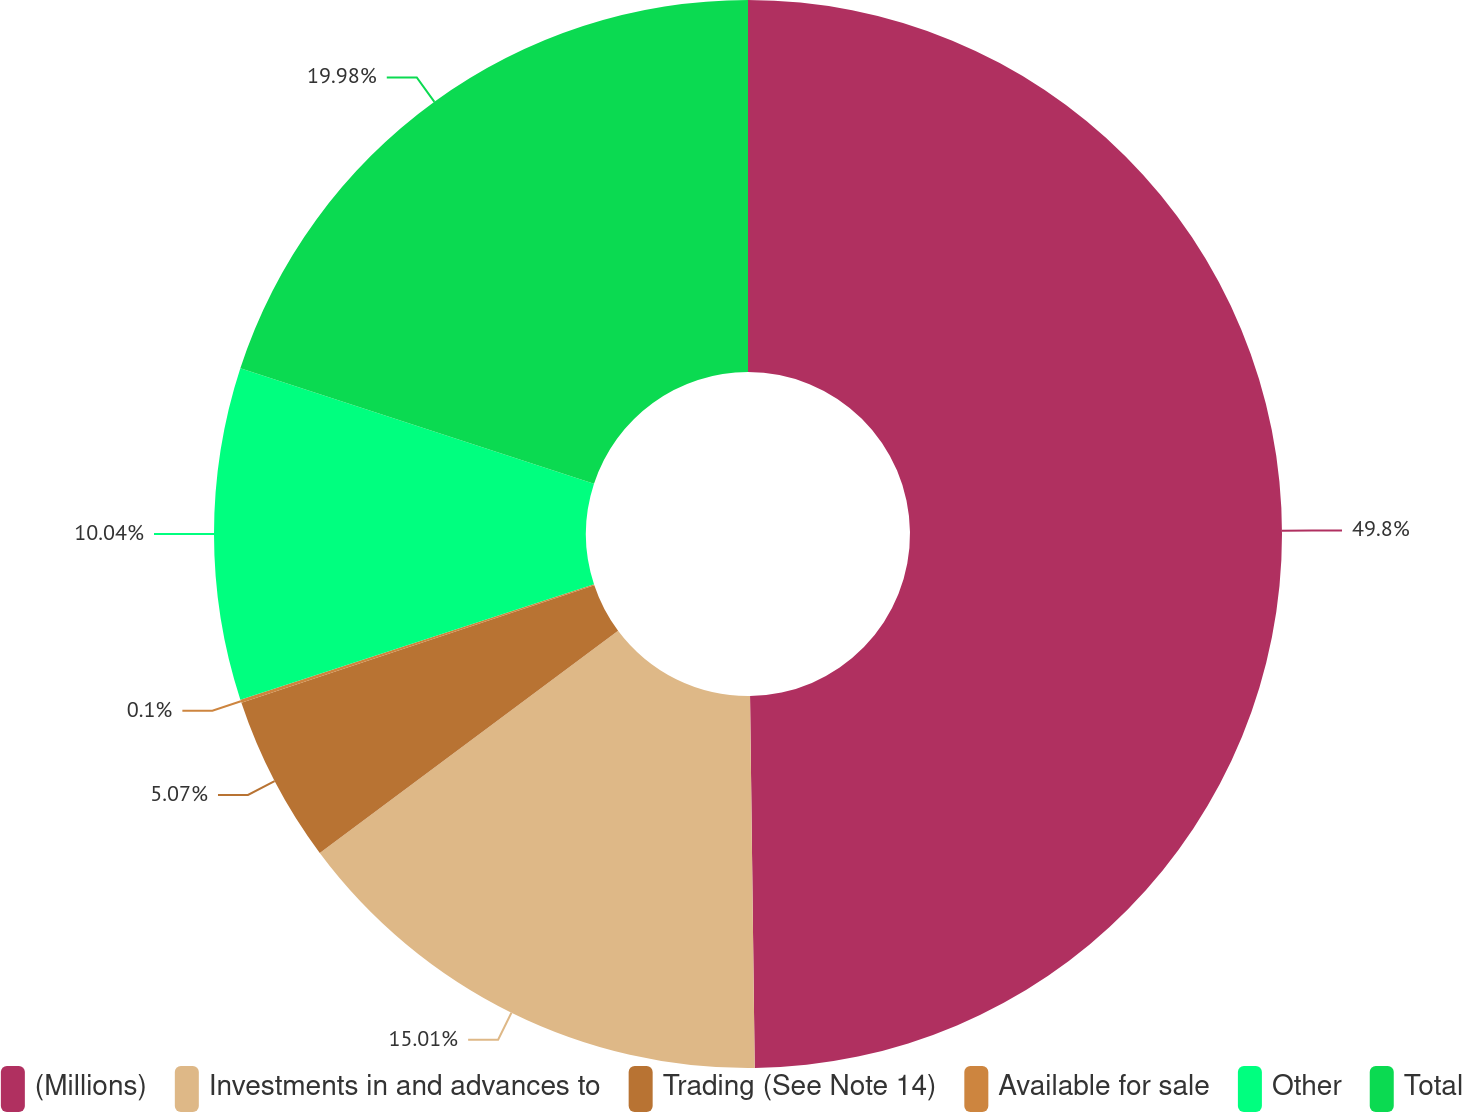Convert chart. <chart><loc_0><loc_0><loc_500><loc_500><pie_chart><fcel>(Millions)<fcel>Investments in and advances to<fcel>Trading (See Note 14)<fcel>Available for sale<fcel>Other<fcel>Total<nl><fcel>49.8%<fcel>15.01%<fcel>5.07%<fcel>0.1%<fcel>10.04%<fcel>19.98%<nl></chart> 